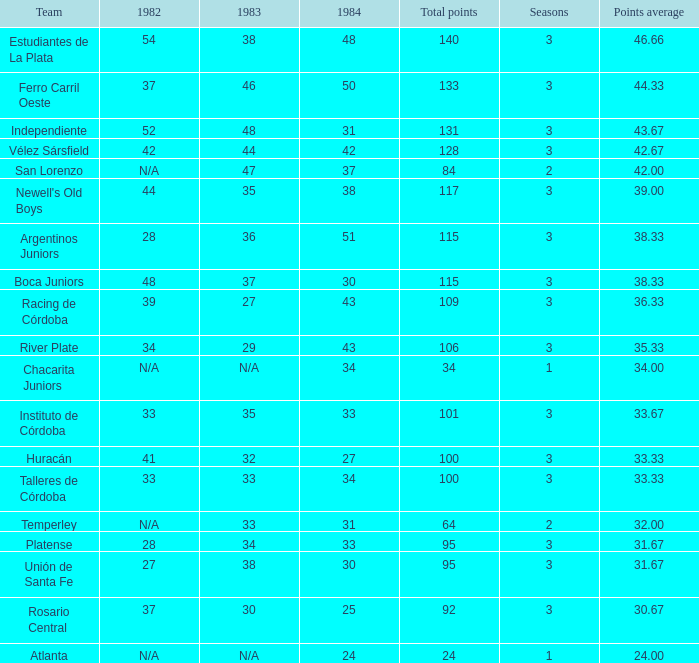Parse the table in full. {'header': ['Team', '1982', '1983', '1984', 'Total points', 'Seasons', 'Points average'], 'rows': [['Estudiantes de La Plata', '54', '38', '48', '140', '3', '46.66'], ['Ferro Carril Oeste', '37', '46', '50', '133', '3', '44.33'], ['Independiente', '52', '48', '31', '131', '3', '43.67'], ['Vélez Sársfield', '42', '44', '42', '128', '3', '42.67'], ['San Lorenzo', 'N/A', '47', '37', '84', '2', '42.00'], ["Newell's Old Boys", '44', '35', '38', '117', '3', '39.00'], ['Argentinos Juniors', '28', '36', '51', '115', '3', '38.33'], ['Boca Juniors', '48', '37', '30', '115', '3', '38.33'], ['Racing de Córdoba', '39', '27', '43', '109', '3', '36.33'], ['River Plate', '34', '29', '43', '106', '3', '35.33'], ['Chacarita Juniors', 'N/A', 'N/A', '34', '34', '1', '34.00'], ['Instituto de Córdoba', '33', '35', '33', '101', '3', '33.67'], ['Huracán', '41', '32', '27', '100', '3', '33.33'], ['Talleres de Córdoba', '33', '33', '34', '100', '3', '33.33'], ['Temperley', 'N/A', '33', '31', '64', '2', '32.00'], ['Platense', '28', '34', '33', '95', '3', '31.67'], ['Unión de Santa Fe', '27', '38', '30', '95', '3', '31.67'], ['Rosario Central', '37', '30', '25', '92', '3', '30.67'], ['Atlanta', 'N/A', 'N/A', '24', '24', '1', '24.00']]} What squad experienced 3 seasons and under 27 in 1984? Rosario Central. 